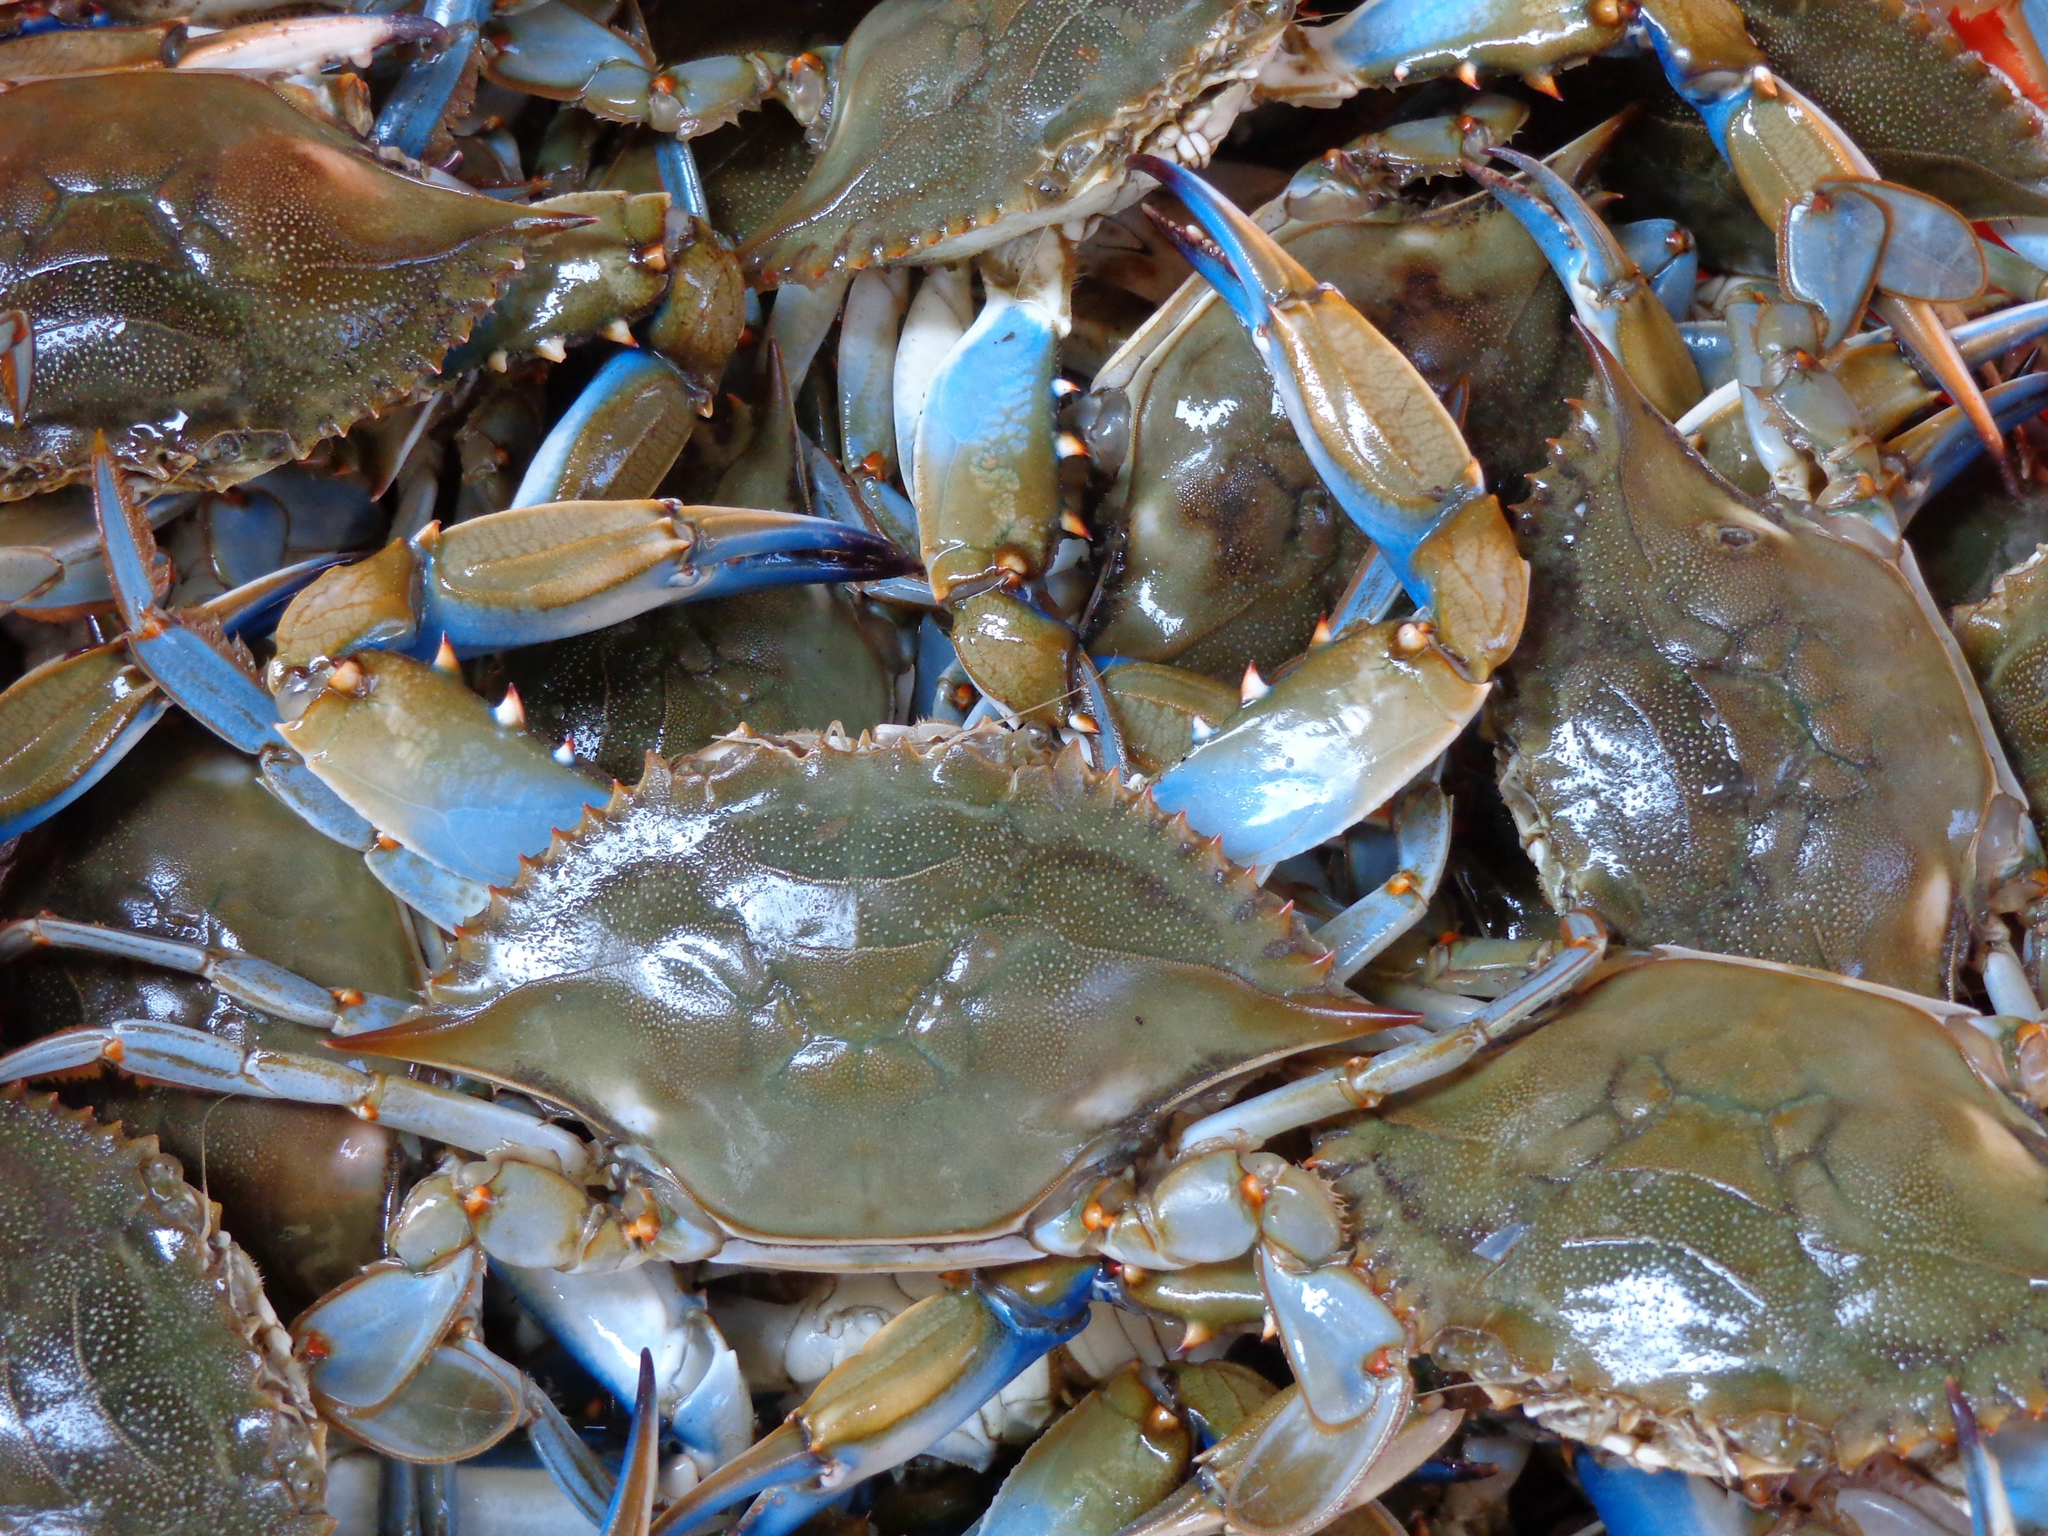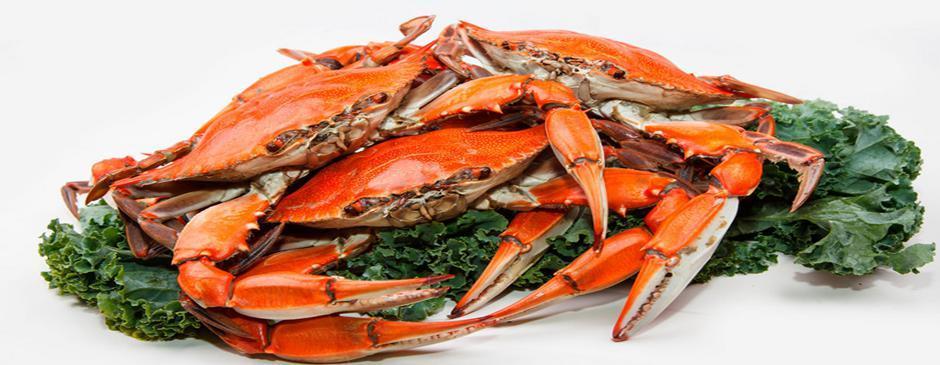The first image is the image on the left, the second image is the image on the right. Analyze the images presented: Is the assertion "The left image is a top-view of a pile of blue-gray crabs, and the right image is a more head-on view of multiple red-orange crabs." valid? Answer yes or no. Yes. The first image is the image on the left, the second image is the image on the right. Analyze the images presented: Is the assertion "There is one pile of gray crabs and one pile of red crabs." valid? Answer yes or no. Yes. 